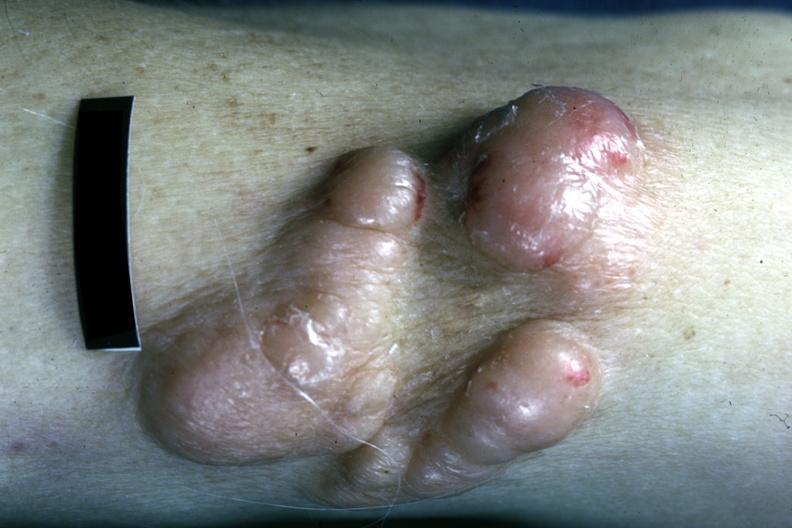where is this?
Answer the question using a single word or phrase. Skin 